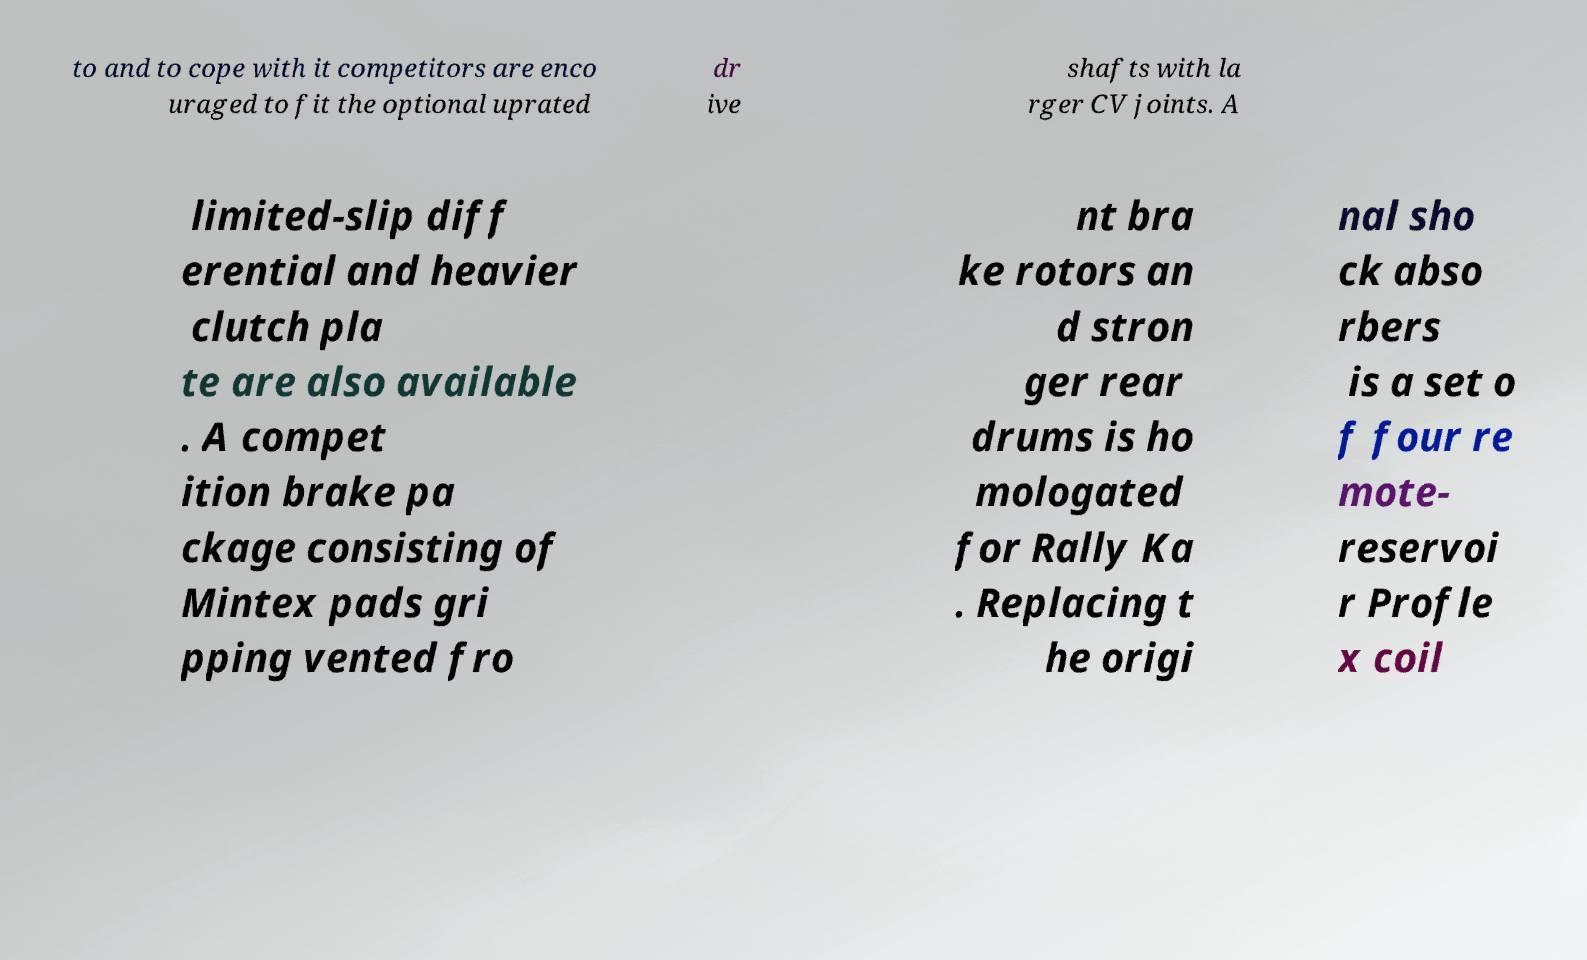Can you accurately transcribe the text from the provided image for me? to and to cope with it competitors are enco uraged to fit the optional uprated dr ive shafts with la rger CV joints. A limited-slip diff erential and heavier clutch pla te are also available . A compet ition brake pa ckage consisting of Mintex pads gri pping vented fro nt bra ke rotors an d stron ger rear drums is ho mologated for Rally Ka . Replacing t he origi nal sho ck abso rbers is a set o f four re mote- reservoi r Profle x coil 